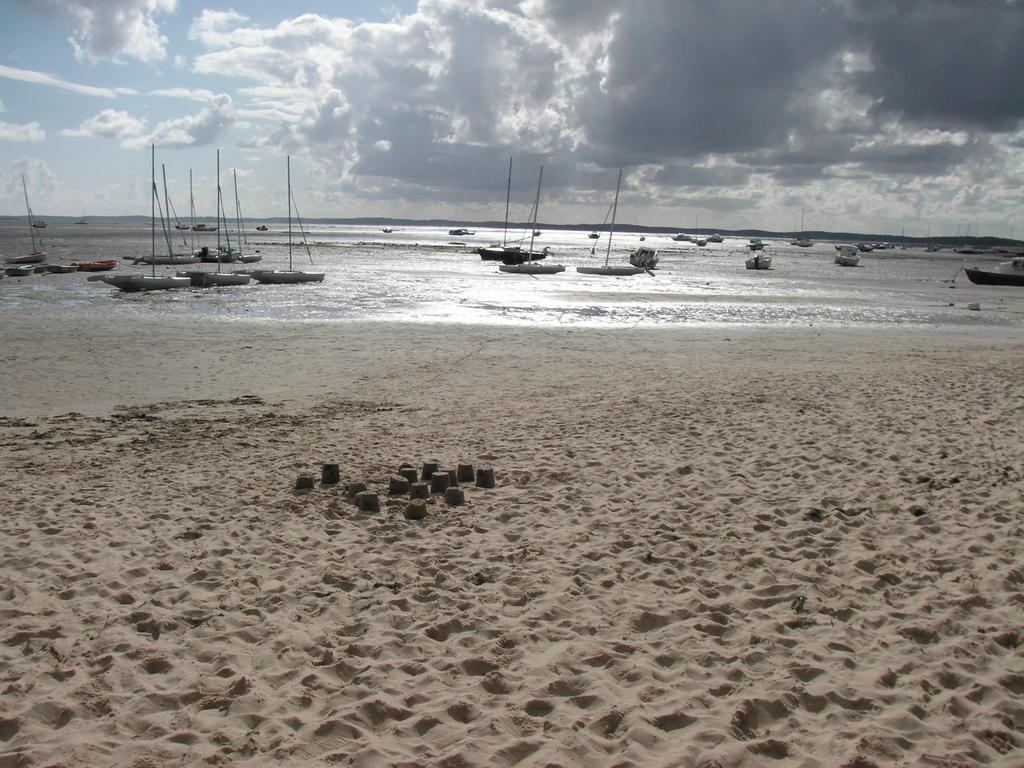Please provide a concise description of this image. In this picture there are boats on the water. At the top there is sky and there are clouds. At the bottom there is sand and water. 